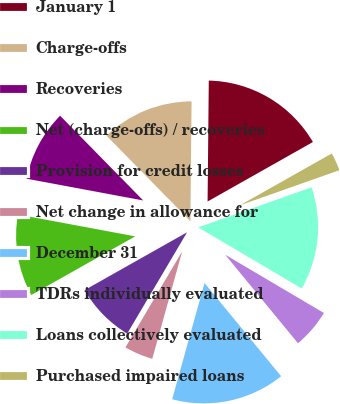<chart> <loc_0><loc_0><loc_500><loc_500><pie_chart><fcel>January 1<fcel>Charge-offs<fcel>Recoveries<fcel>Net (charge-offs) / recoveries<fcel>Provision for credit losses<fcel>Net change in allowance for<fcel>December 31<fcel>TDRs individually evaluated<fcel>Loans collectively evaluated<fcel>Purchased impaired loans<nl><fcel>16.66%<fcel>12.5%<fcel>9.72%<fcel>11.11%<fcel>8.33%<fcel>4.17%<fcel>15.27%<fcel>5.56%<fcel>13.89%<fcel>2.78%<nl></chart> 